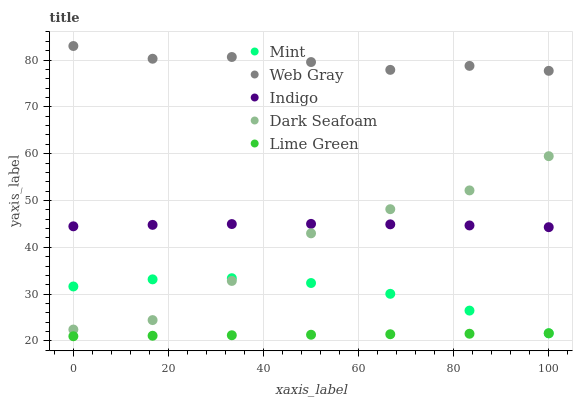Does Lime Green have the minimum area under the curve?
Answer yes or no. Yes. Does Web Gray have the maximum area under the curve?
Answer yes or no. Yes. Does Dark Seafoam have the minimum area under the curve?
Answer yes or no. No. Does Dark Seafoam have the maximum area under the curve?
Answer yes or no. No. Is Lime Green the smoothest?
Answer yes or no. Yes. Is Dark Seafoam the roughest?
Answer yes or no. Yes. Is Web Gray the smoothest?
Answer yes or no. No. Is Web Gray the roughest?
Answer yes or no. No. Does Lime Green have the lowest value?
Answer yes or no. Yes. Does Dark Seafoam have the lowest value?
Answer yes or no. No. Does Web Gray have the highest value?
Answer yes or no. Yes. Does Dark Seafoam have the highest value?
Answer yes or no. No. Is Lime Green less than Dark Seafoam?
Answer yes or no. Yes. Is Dark Seafoam greater than Lime Green?
Answer yes or no. Yes. Does Mint intersect Lime Green?
Answer yes or no. Yes. Is Mint less than Lime Green?
Answer yes or no. No. Is Mint greater than Lime Green?
Answer yes or no. No. Does Lime Green intersect Dark Seafoam?
Answer yes or no. No. 